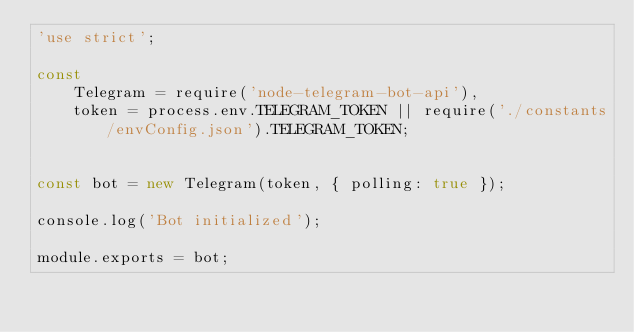Convert code to text. <code><loc_0><loc_0><loc_500><loc_500><_JavaScript_>'use strict';

const
    Telegram = require('node-telegram-bot-api'),
    token = process.env.TELEGRAM_TOKEN || require('./constants/envConfig.json').TELEGRAM_TOKEN;


const bot = new Telegram(token, { polling: true });

console.log('Bot initialized');

module.exports = bot;
</code> 